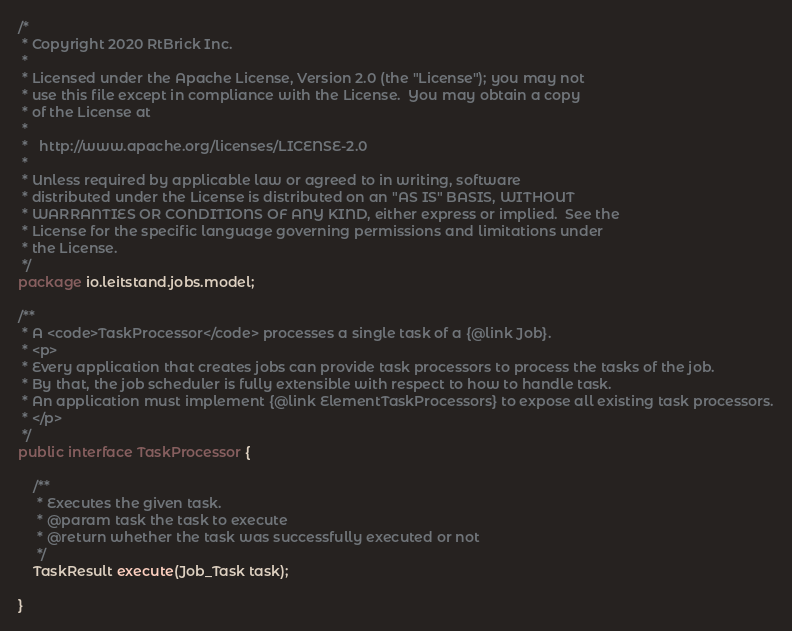Convert code to text. <code><loc_0><loc_0><loc_500><loc_500><_Java_>/*
 * Copyright 2020 RtBrick Inc.
 * 
 * Licensed under the Apache License, Version 2.0 (the "License"); you may not
 * use this file except in compliance with the License.  You may obtain a copy
 * of the License at
 * 
 *   http://www.apache.org/licenses/LICENSE-2.0
 * 
 * Unless required by applicable law or agreed to in writing, software
 * distributed under the License is distributed on an "AS IS" BASIS, WITHOUT
 * WARRANTIES OR CONDITIONS OF ANY KIND, either express or implied.  See the
 * License for the specific language governing permissions and limitations under
 * the License.
 */
package io.leitstand.jobs.model;

/**
 * A <code>TaskProcessor</code> processes a single task of a {@link Job}.
 * <p>
 * Every application that creates jobs can provide task processors to process the tasks of the job.
 * By that, the job scheduler is fully extensible with respect to how to handle task.
 * An application must implement {@link ElementTaskProcessors} to expose all existing task processors.
 * </p>
 */
public interface TaskProcessor {
	
    /**
     * Executes the given task.
     * @param task the task to execute
     * @return whether the task was successfully executed or not
     */
	TaskResult execute(Job_Task task);
	
}</code> 